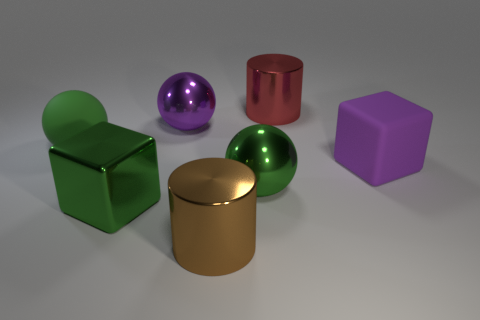What is the size of the metal object that is the same color as the matte cube?
Keep it short and to the point. Large. There is a matte ball that is the same size as the red metallic cylinder; what color is it?
Give a very brief answer. Green. Is the large cylinder that is on the left side of the red shiny object made of the same material as the large green block?
Your response must be concise. Yes. There is a large metallic cylinder that is in front of the big ball left of the green metallic cube; are there any purple things that are on the right side of it?
Your answer should be compact. Yes. Do the large matte thing on the left side of the large purple shiny thing and the purple shiny object have the same shape?
Offer a terse response. Yes. There is a large purple thing right of the big metallic thing that is in front of the large metallic block; what shape is it?
Your answer should be compact. Cube. There is a purple object that is left of the ball in front of the purple object that is in front of the green rubber sphere; what size is it?
Ensure brevity in your answer.  Large. What is the color of the other large metal thing that is the same shape as the big red metallic thing?
Keep it short and to the point. Brown. What is the material of the big green ball to the left of the brown cylinder?
Your answer should be very brief. Rubber. What number of other things are there of the same shape as the large red thing?
Give a very brief answer. 1. 